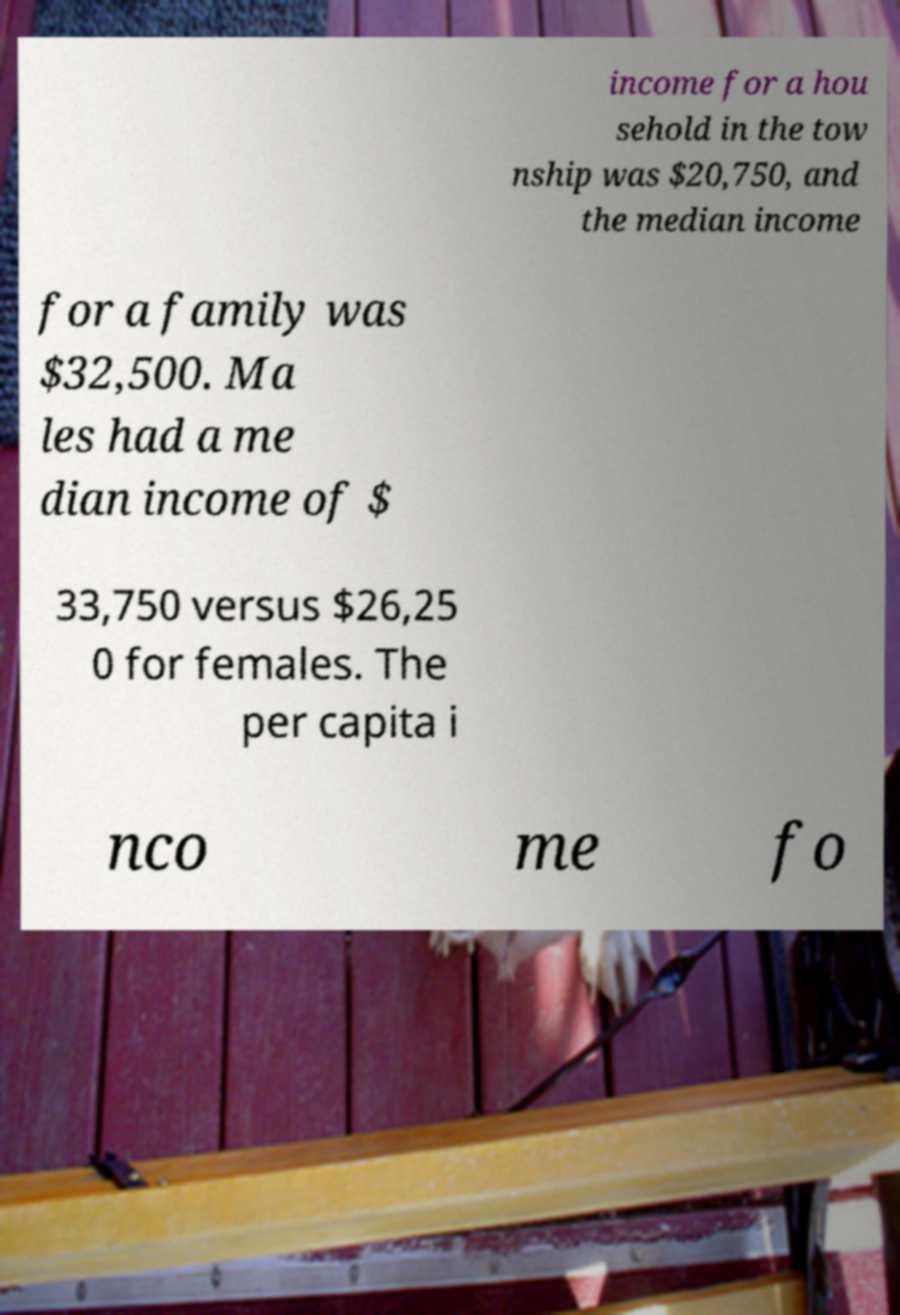Please read and relay the text visible in this image. What does it say? income for a hou sehold in the tow nship was $20,750, and the median income for a family was $32,500. Ma les had a me dian income of $ 33,750 versus $26,25 0 for females. The per capita i nco me fo 